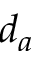<formula> <loc_0><loc_0><loc_500><loc_500>d _ { a }</formula> 